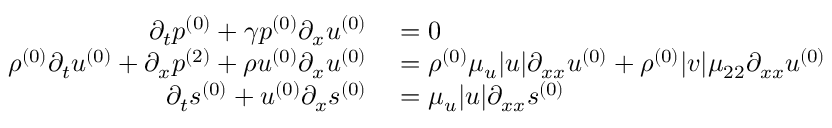<formula> <loc_0><loc_0><loc_500><loc_500>\begin{array} { r l } { \partial _ { t } { p ^ { ( 0 ) } } + \gamma { p ^ { ( 0 ) } } \partial _ { x } { u ^ { ( 0 ) } } } & = 0 } \\ { { \rho ^ { ( 0 ) } } \partial _ { t } { u ^ { ( 0 ) } } + \partial _ { x } { p ^ { ( 2 ) } } + { \rho u ^ { ( 0 ) } } \partial _ { x } { u ^ { ( 0 ) } } } & = { \rho ^ { ( 0 ) } } \mu _ { u } | u | \partial _ { x x } { u ^ { ( 0 ) } } + { \rho ^ { ( 0 ) } } | v | \mu _ { 2 2 } \partial _ { x x } { u ^ { ( 0 ) } } } \\ { \partial _ { t } { s ^ { ( 0 ) } } + { u ^ { ( 0 ) } } \partial _ { x } { s ^ { ( 0 ) } } } & = \mu _ { u } | u | \partial _ { x x } { s ^ { ( 0 ) } } } \end{array}</formula> 